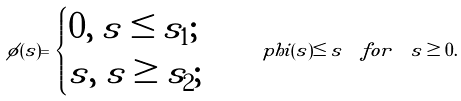Convert formula to latex. <formula><loc_0><loc_0><loc_500><loc_500>\phi ( s ) = \begin{cases} 0 , \ s \leq s _ { 1 } ; \\ s , \ s \geq s _ { 2 } ; \end{cases} \quad p h i ( s ) \leq s \ \ f o r \ \ s \geq 0 .</formula> 